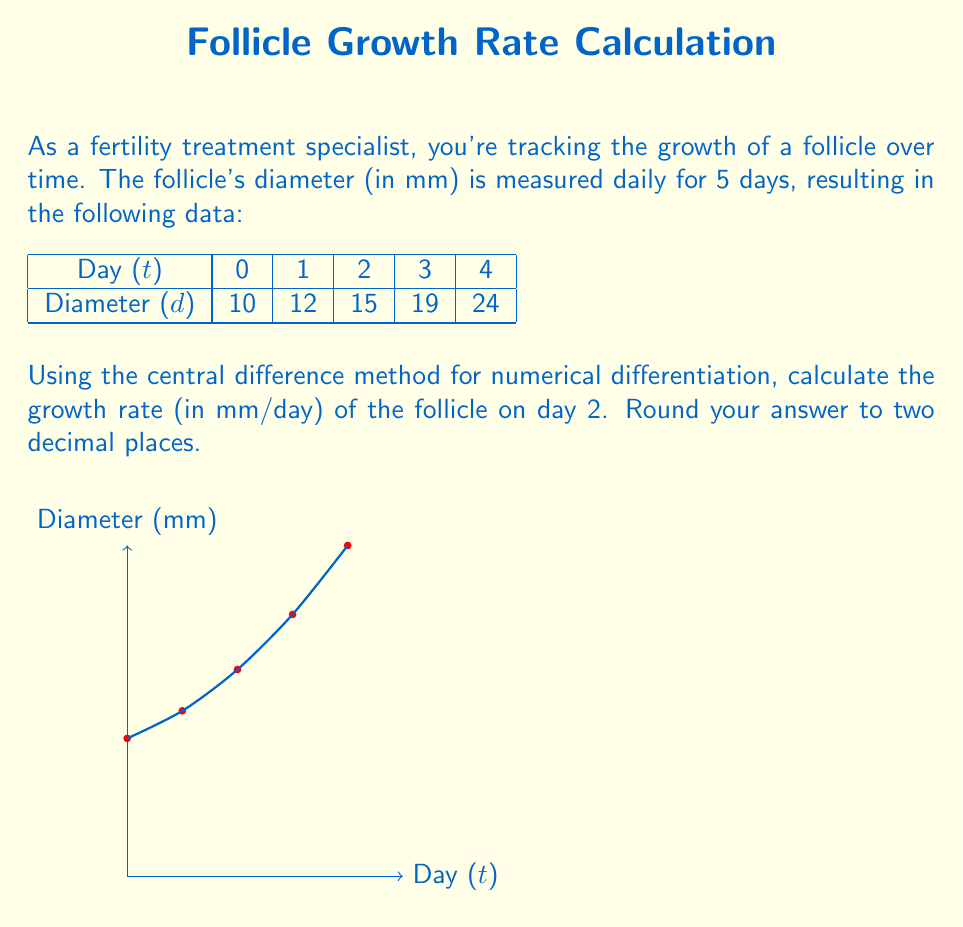Solve this math problem. To solve this problem, we'll use the central difference method for numerical differentiation. The formula for the central difference approximation of the first derivative is:

$$ f'(x) \approx \frac{f(x+h) - f(x-h)}{2h} $$

Where $h$ is the step size between data points.

Steps:
1) In our case, $h = 1$ day, and we want to calculate the growth rate at $t = 2$ days.

2) We need the diameter values at $t = 1$ and $t = 3$:
   $f(x-h) = f(1) = 12$ mm
   $f(x+h) = f(3) = 19$ mm

3) Plugging these into the central difference formula:

   $$ f'(2) \approx \frac{f(3) - f(1)}{2(1)} = \frac{19 - 12}{2} = \frac{7}{2} = 3.5 $$

4) The growth rate at day 2 is approximately 3.5 mm/day.

5) Rounding to two decimal places: 3.50 mm/day.

This method provides a good approximation of the instantaneous growth rate at day 2, using the follicle sizes from the day before and after.
Answer: 3.50 mm/day 